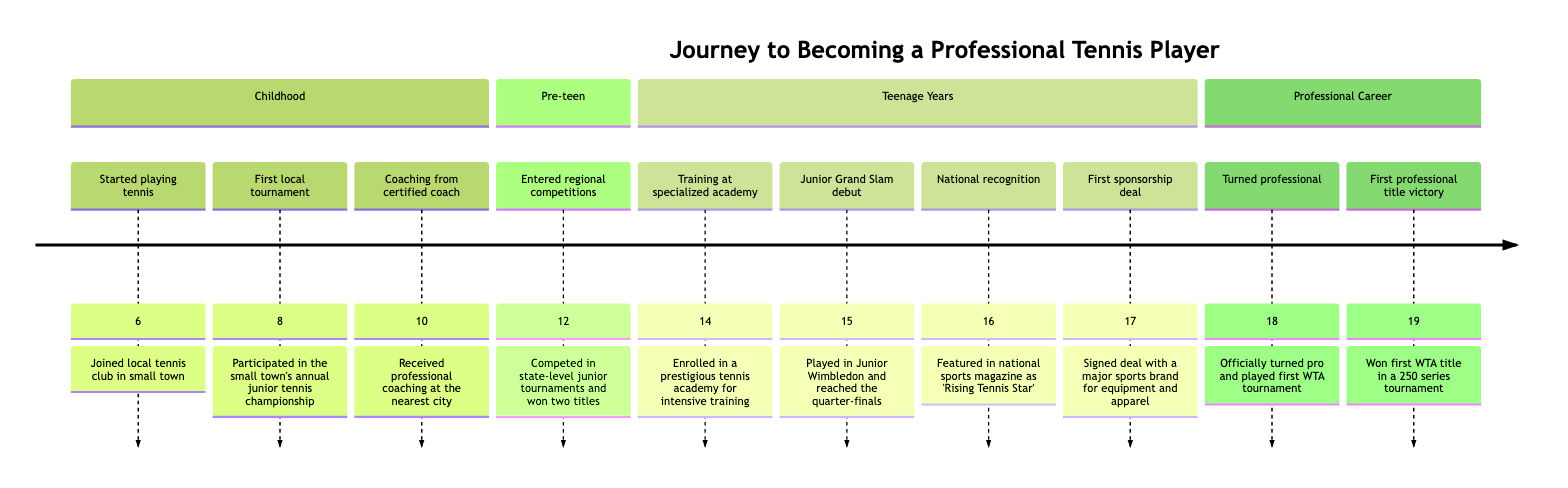What age did you start playing tennis? The timeline indicates that the first event is "Started playing tennis," which occurred at age 6.
Answer: 6 How many years did you participate in local tournaments before regional competitions? The first local tournament took place at age 8, and entry into regional competitions began at age 12. Therefore, the time between these events is 12 - 8 = 4 years.
Answer: 4 years At what age did you achieve national recognition? The event "National recognition" is listed as occurring at age 16 according to the diagram.
Answer: 16 What significant achievement happened at age 15? According to the timeline, at age 15, there was a "Junior Grand Slam debut," where the player reached the quarter-finals at Junior Wimbledon.
Answer: Junior Grand Slam debut What event marks the transition from a junior player to a professional? The timeline clearly states that the event marking the transition is "Turned professional," which occurred at age 18.
Answer: Turned professional Which event occurred immediately before the first professional title victory? According to the timeline, the event "Turned professional" occurred at age 18, and "First professional title victory" occurred at age 19. Therefore, "Turned professional" is the immediate predecessor.
Answer: Turned professional How old was the player when they signed their first sponsorship deal? The diagram shows that the first sponsorship deal occurred at age 17.
Answer: 17 What title was given to the player at age 16? The timeline states that at age 16, the player was featured as a "Rising Tennis Star" in a national sports magazine.
Answer: Rising Tennis Star How many key milestones are shown in the timeline? Counting the events listed, there are ten key milestones represented in the timeline.
Answer: 10 